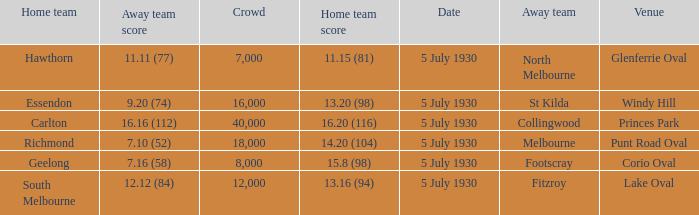What day does the team play at punt road oval? 5 July 1930. 